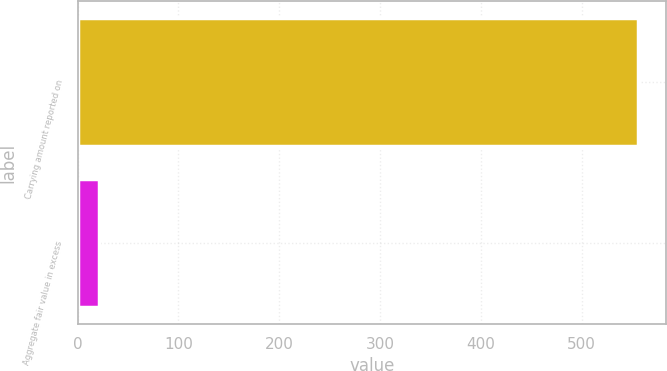Convert chart. <chart><loc_0><loc_0><loc_500><loc_500><bar_chart><fcel>Carrying amount reported on<fcel>Aggregate fair value in excess<nl><fcel>556<fcel>21<nl></chart> 